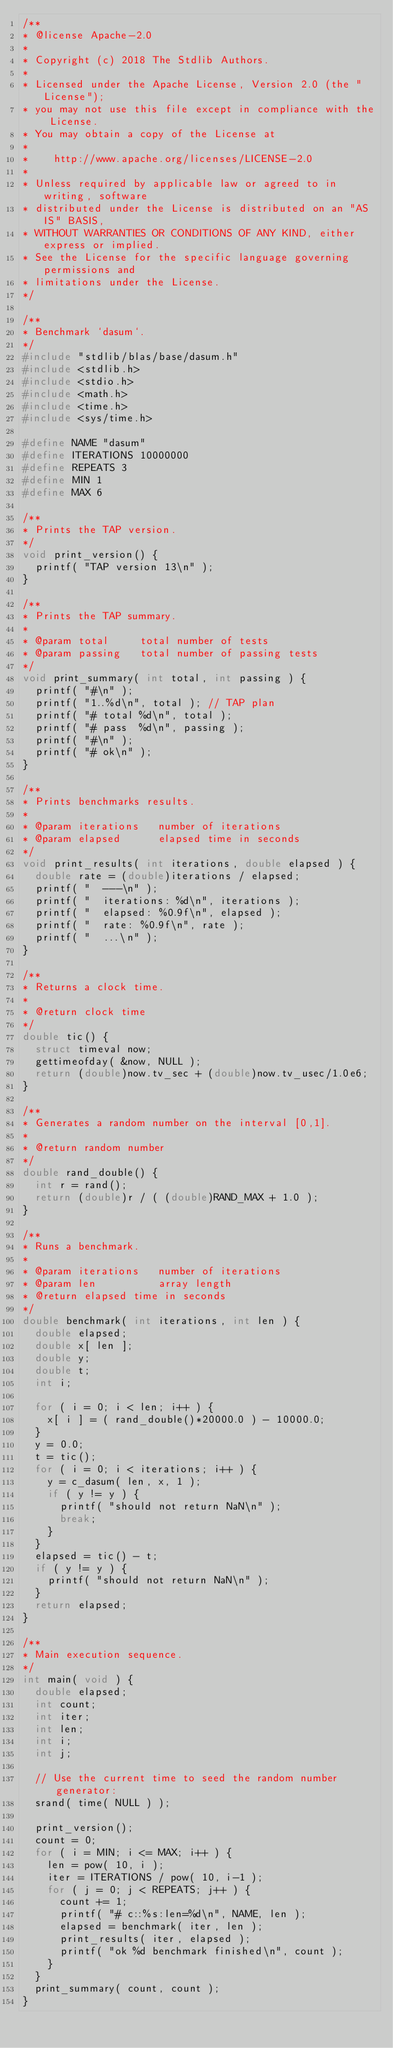Convert code to text. <code><loc_0><loc_0><loc_500><loc_500><_C_>/**
* @license Apache-2.0
*
* Copyright (c) 2018 The Stdlib Authors.
*
* Licensed under the Apache License, Version 2.0 (the "License");
* you may not use this file except in compliance with the License.
* You may obtain a copy of the License at
*
*    http://www.apache.org/licenses/LICENSE-2.0
*
* Unless required by applicable law or agreed to in writing, software
* distributed under the License is distributed on an "AS IS" BASIS,
* WITHOUT WARRANTIES OR CONDITIONS OF ANY KIND, either express or implied.
* See the License for the specific language governing permissions and
* limitations under the License.
*/

/**
* Benchmark `dasum`.
*/
#include "stdlib/blas/base/dasum.h"
#include <stdlib.h>
#include <stdio.h>
#include <math.h>
#include <time.h>
#include <sys/time.h>

#define NAME "dasum"
#define ITERATIONS 10000000
#define REPEATS 3
#define MIN 1
#define MAX 6

/**
* Prints the TAP version.
*/
void print_version() {
	printf( "TAP version 13\n" );
}

/**
* Prints the TAP summary.
*
* @param total     total number of tests
* @param passing   total number of passing tests
*/
void print_summary( int total, int passing ) {
	printf( "#\n" );
	printf( "1..%d\n", total ); // TAP plan
	printf( "# total %d\n", total );
	printf( "# pass  %d\n", passing );
	printf( "#\n" );
	printf( "# ok\n" );
}

/**
* Prints benchmarks results.
*
* @param iterations   number of iterations
* @param elapsed      elapsed time in seconds
*/
void print_results( int iterations, double elapsed ) {
	double rate = (double)iterations / elapsed;
	printf( "  ---\n" );
	printf( "  iterations: %d\n", iterations );
	printf( "  elapsed: %0.9f\n", elapsed );
	printf( "  rate: %0.9f\n", rate );
	printf( "  ...\n" );
}

/**
* Returns a clock time.
*
* @return clock time
*/
double tic() {
	struct timeval now;
	gettimeofday( &now, NULL );
	return (double)now.tv_sec + (double)now.tv_usec/1.0e6;
}

/**
* Generates a random number on the interval [0,1].
*
* @return random number
*/
double rand_double() {
	int r = rand();
	return (double)r / ( (double)RAND_MAX + 1.0 );
}

/**
* Runs a benchmark.
*
* @param iterations   number of iterations
* @param len          array length
* @return elapsed time in seconds
*/
double benchmark( int iterations, int len ) {
	double elapsed;
	double x[ len ];
	double y;
	double t;
	int i;

	for ( i = 0; i < len; i++ ) {
		x[ i ] = ( rand_double()*20000.0 ) - 10000.0;
	}
	y = 0.0;
	t = tic();
	for ( i = 0; i < iterations; i++ ) {
		y = c_dasum( len, x, 1 );
		if ( y != y ) {
			printf( "should not return NaN\n" );
			break;
		}
	}
	elapsed = tic() - t;
	if ( y != y ) {
		printf( "should not return NaN\n" );
	}
	return elapsed;
}

/**
* Main execution sequence.
*/
int main( void ) {
	double elapsed;
	int count;
	int iter;
	int len;
	int i;
	int j;

	// Use the current time to seed the random number generator:
	srand( time( NULL ) );

	print_version();
	count = 0;
	for ( i = MIN; i <= MAX; i++ ) {
		len = pow( 10, i );
		iter = ITERATIONS / pow( 10, i-1 );
		for ( j = 0; j < REPEATS; j++ ) {
			count += 1;
			printf( "# c::%s:len=%d\n", NAME, len );
			elapsed = benchmark( iter, len );
			print_results( iter, elapsed );
			printf( "ok %d benchmark finished\n", count );
		}
	}
	print_summary( count, count );
}
</code> 